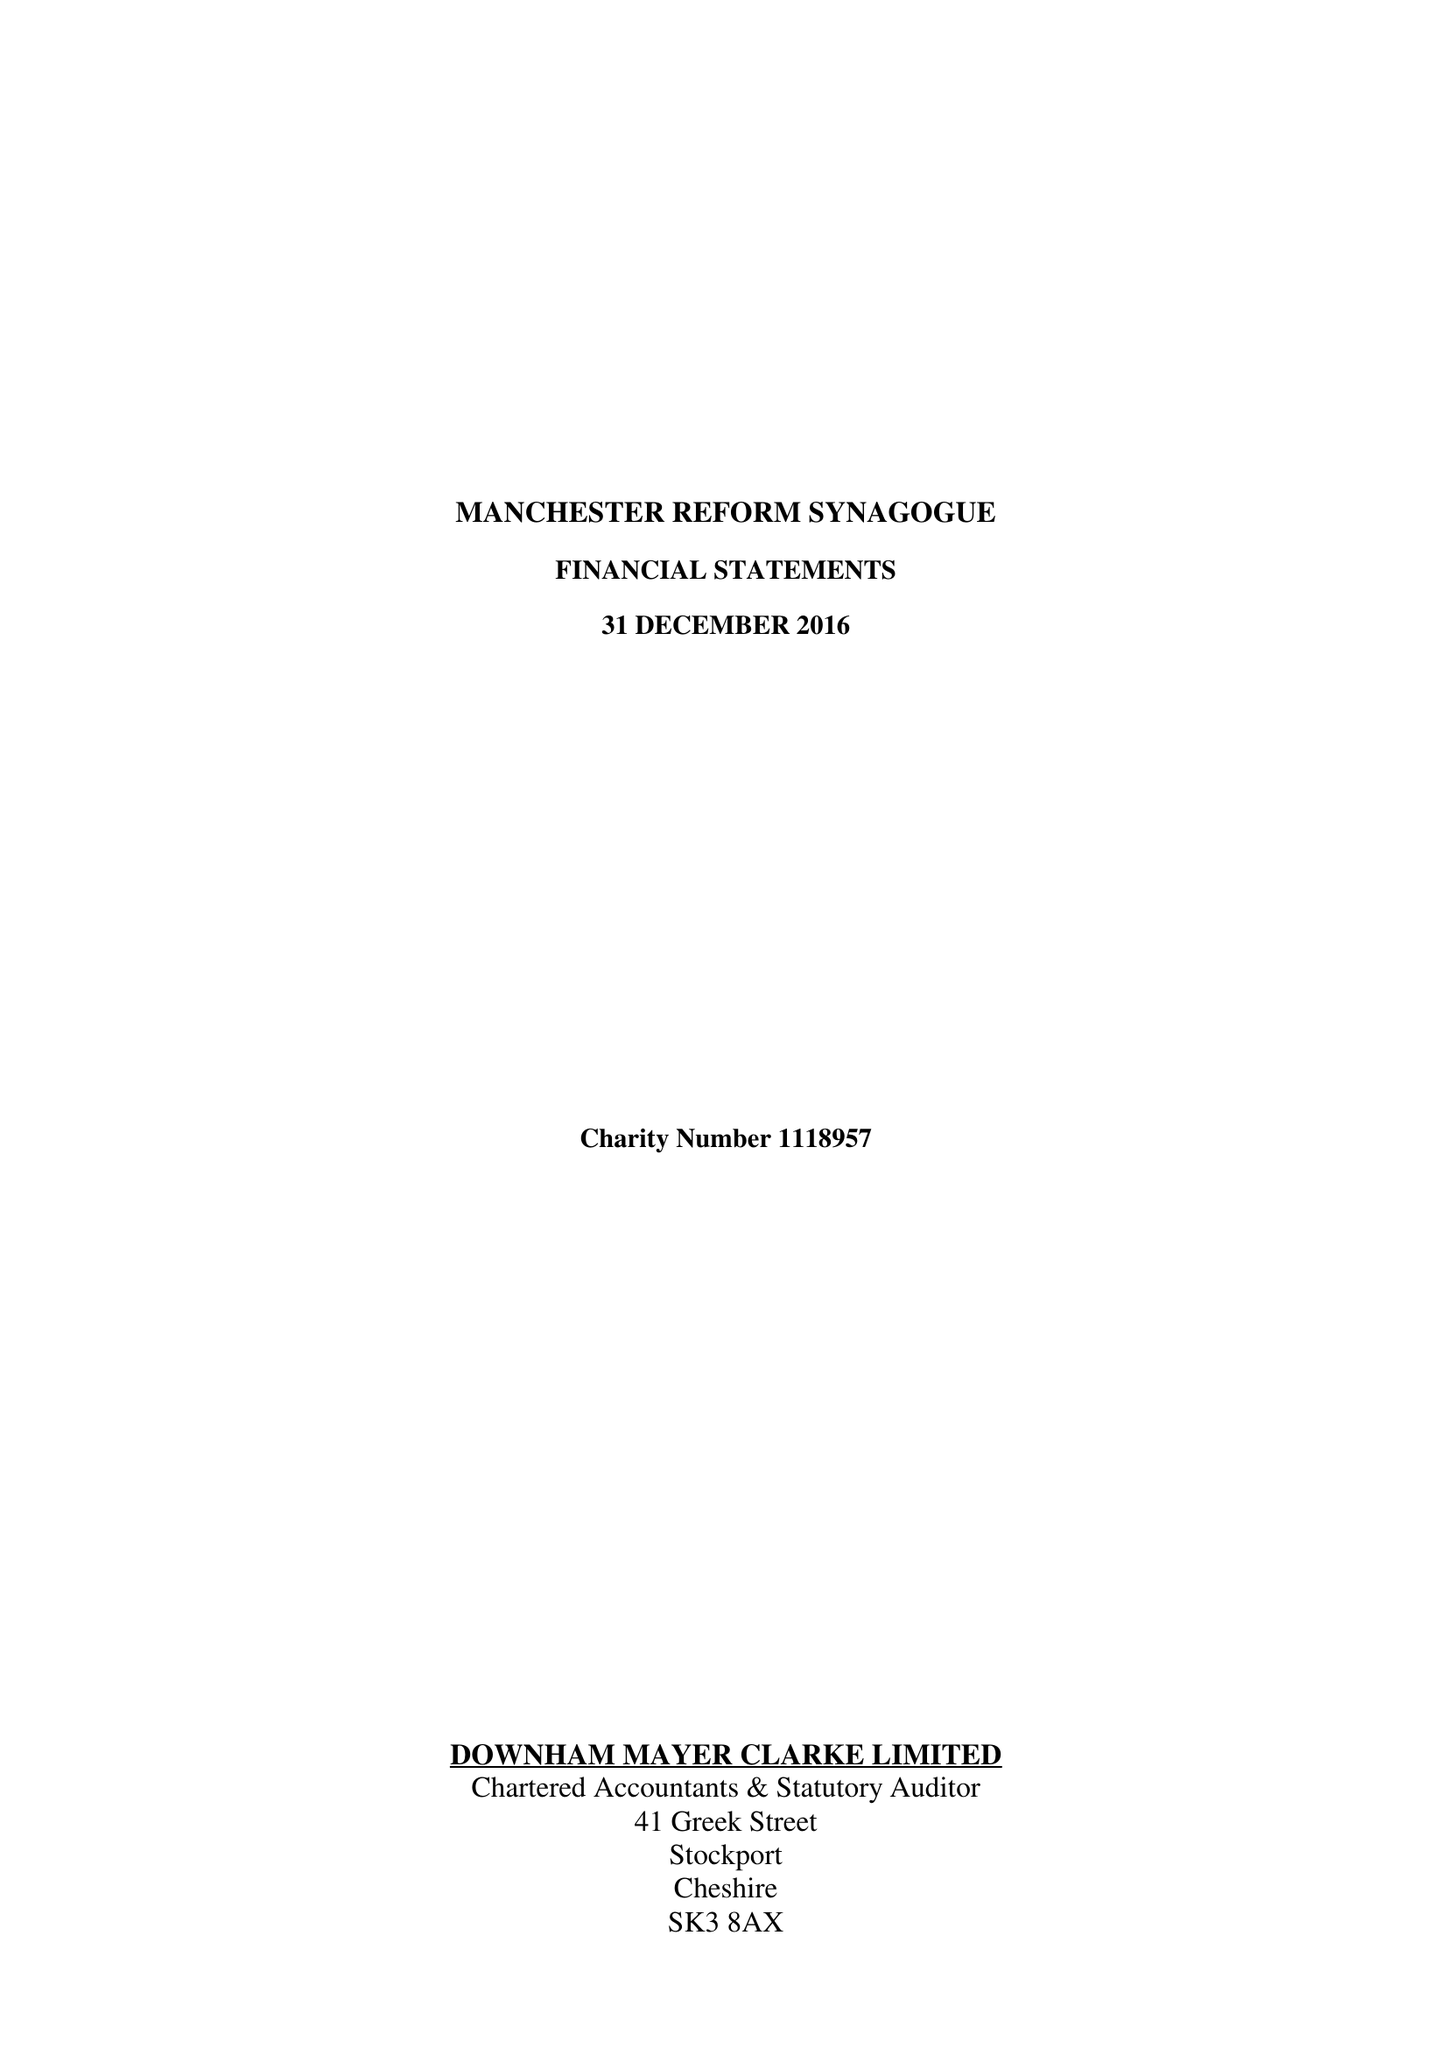What is the value for the spending_annually_in_british_pounds?
Answer the question using a single word or phrase. 320000.00 